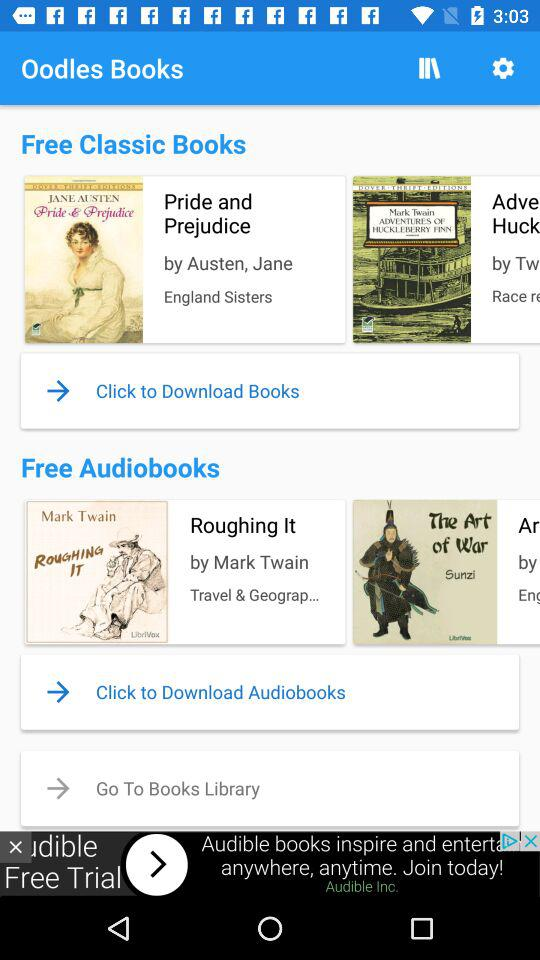What is the name of application? The name of the application is "Oodles Books". 